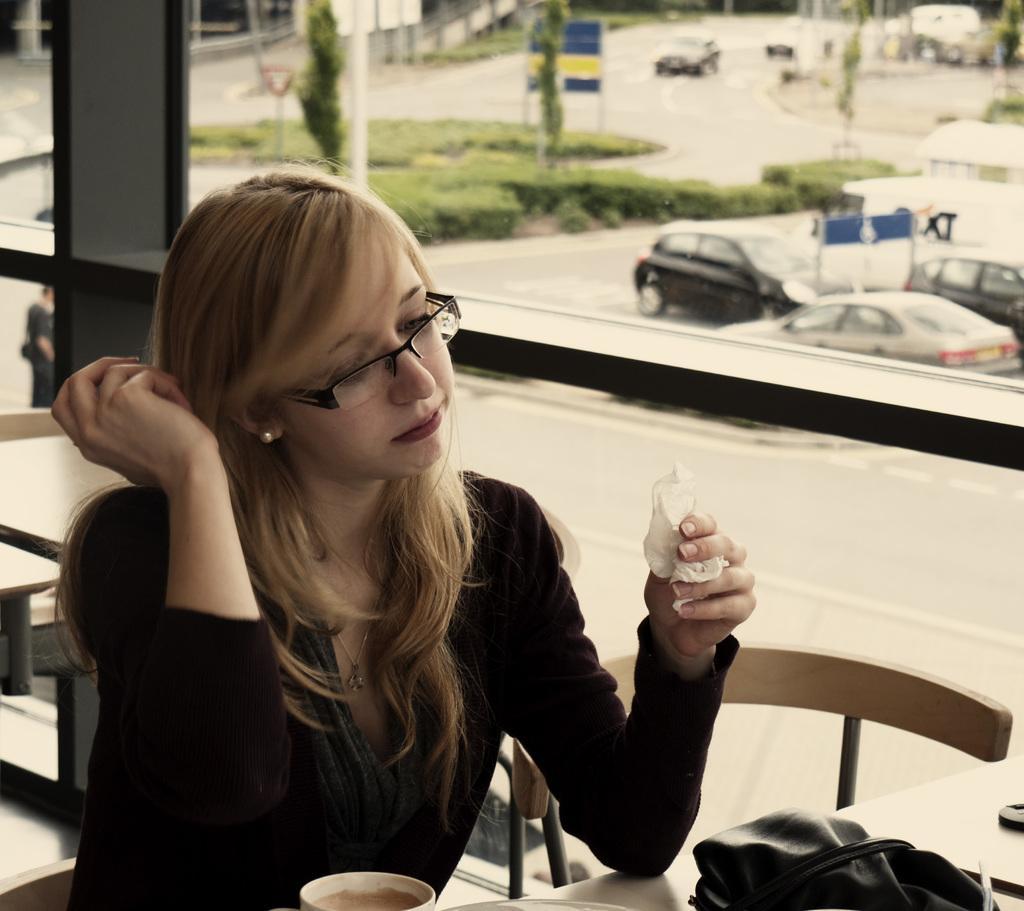How would you summarize this image in a sentence or two? In the image we can see there is a woman who is sitting on chair. 